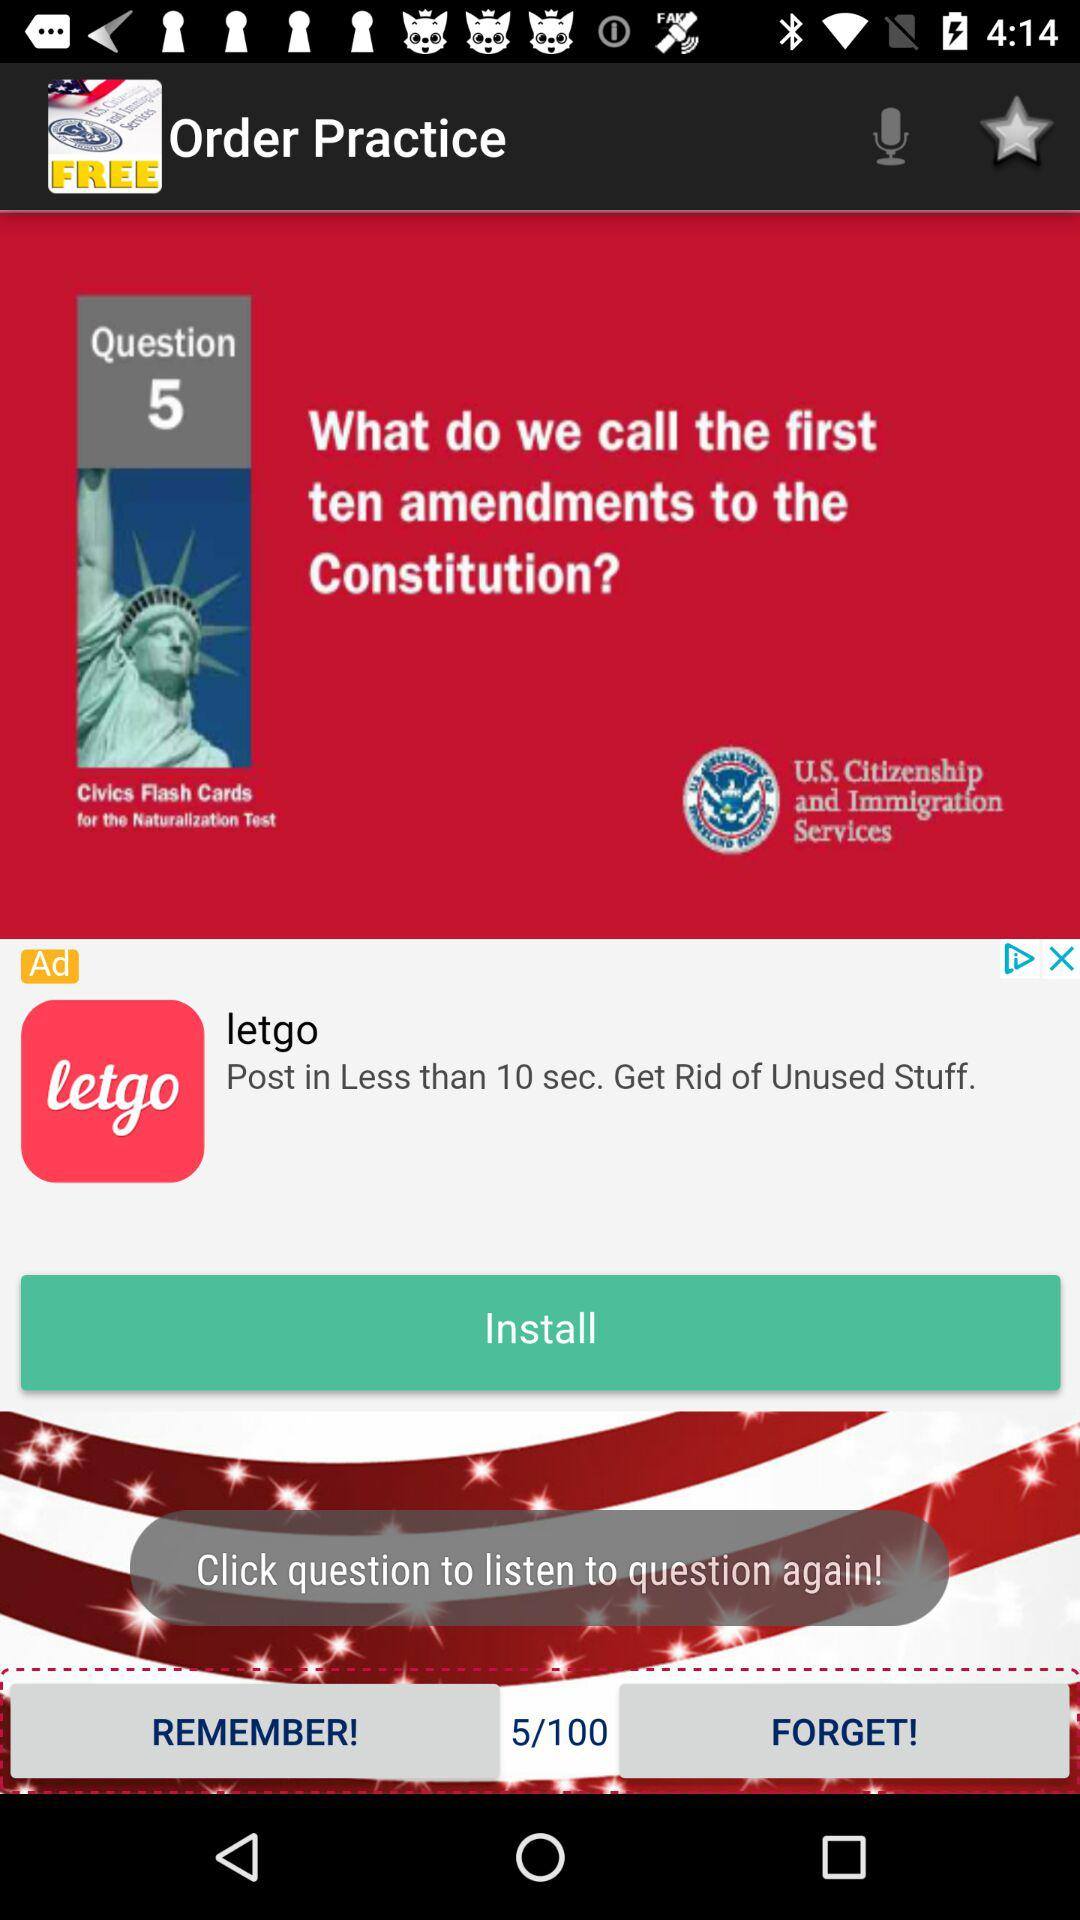What is the application name? The application name is "Order Practice". 